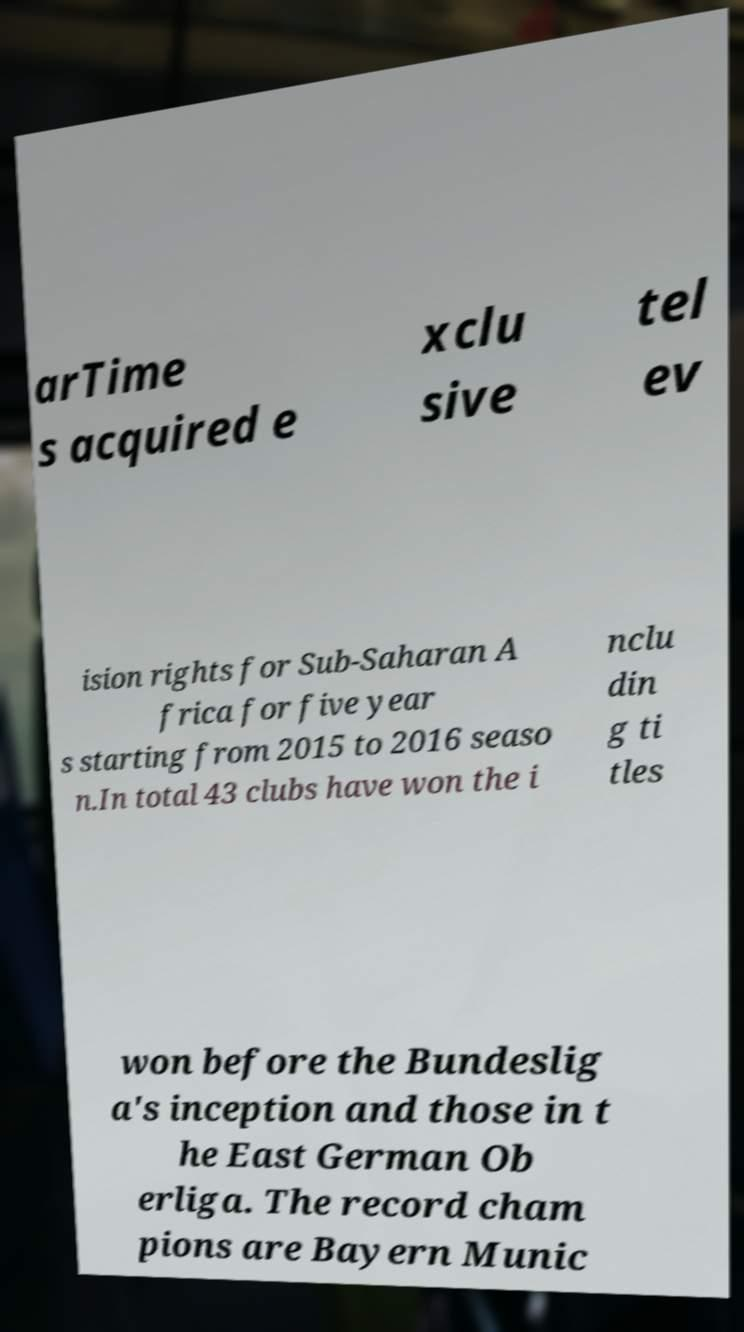Could you assist in decoding the text presented in this image and type it out clearly? arTime s acquired e xclu sive tel ev ision rights for Sub-Saharan A frica for five year s starting from 2015 to 2016 seaso n.In total 43 clubs have won the i nclu din g ti tles won before the Bundeslig a's inception and those in t he East German Ob erliga. The record cham pions are Bayern Munic 